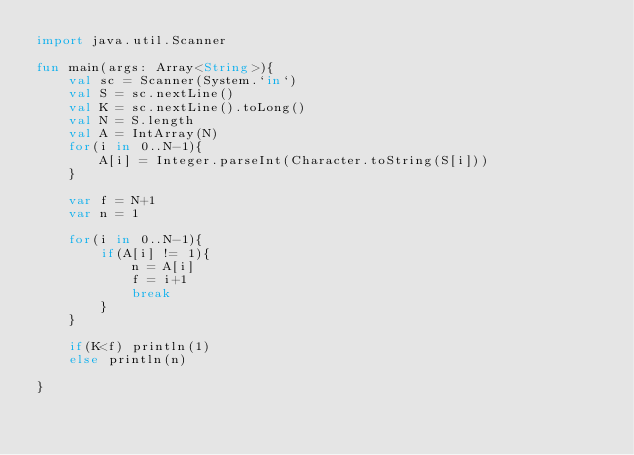Convert code to text. <code><loc_0><loc_0><loc_500><loc_500><_Kotlin_>import java.util.Scanner

fun main(args: Array<String>){
	val sc = Scanner(System.`in`)
	val S = sc.nextLine()
	val K = sc.nextLine().toLong()
	val N = S.length
	val A = IntArray(N)
	for(i in 0..N-1){
		A[i] = Integer.parseInt(Character.toString(S[i]))
	}
	
	var f = N+1
	var n = 1

	for(i in 0..N-1){
		if(A[i] != 1){
			n = A[i]
			f = i+1
			break
		}
	}

	if(K<f) println(1)
	else println(n)

}</code> 